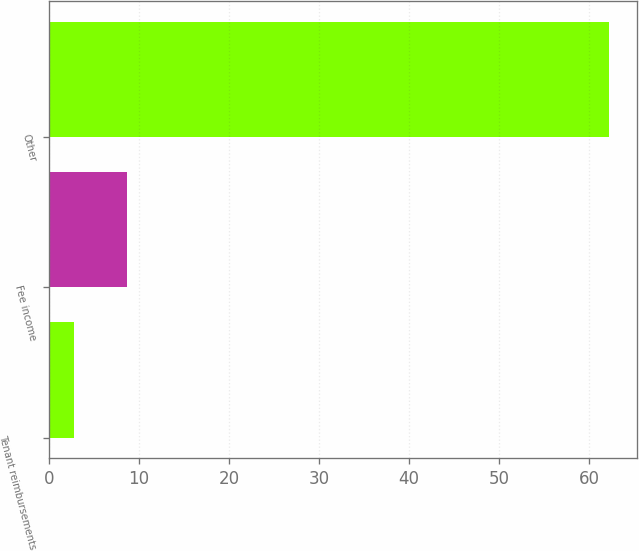Convert chart. <chart><loc_0><loc_0><loc_500><loc_500><bar_chart><fcel>Tenant reimbursements<fcel>Fee income<fcel>Other<nl><fcel>2.8<fcel>8.74<fcel>62.2<nl></chart> 